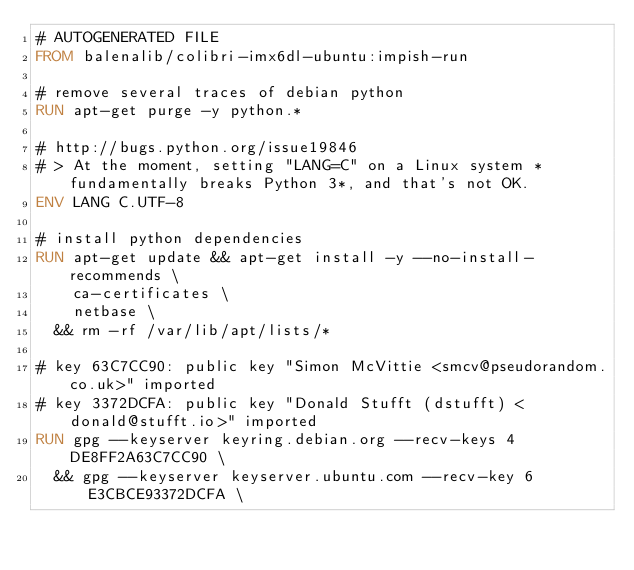<code> <loc_0><loc_0><loc_500><loc_500><_Dockerfile_># AUTOGENERATED FILE
FROM balenalib/colibri-imx6dl-ubuntu:impish-run

# remove several traces of debian python
RUN apt-get purge -y python.*

# http://bugs.python.org/issue19846
# > At the moment, setting "LANG=C" on a Linux system *fundamentally breaks Python 3*, and that's not OK.
ENV LANG C.UTF-8

# install python dependencies
RUN apt-get update && apt-get install -y --no-install-recommends \
		ca-certificates \
		netbase \
	&& rm -rf /var/lib/apt/lists/*

# key 63C7CC90: public key "Simon McVittie <smcv@pseudorandom.co.uk>" imported
# key 3372DCFA: public key "Donald Stufft (dstufft) <donald@stufft.io>" imported
RUN gpg --keyserver keyring.debian.org --recv-keys 4DE8FF2A63C7CC90 \
	&& gpg --keyserver keyserver.ubuntu.com --recv-key 6E3CBCE93372DCFA \</code> 